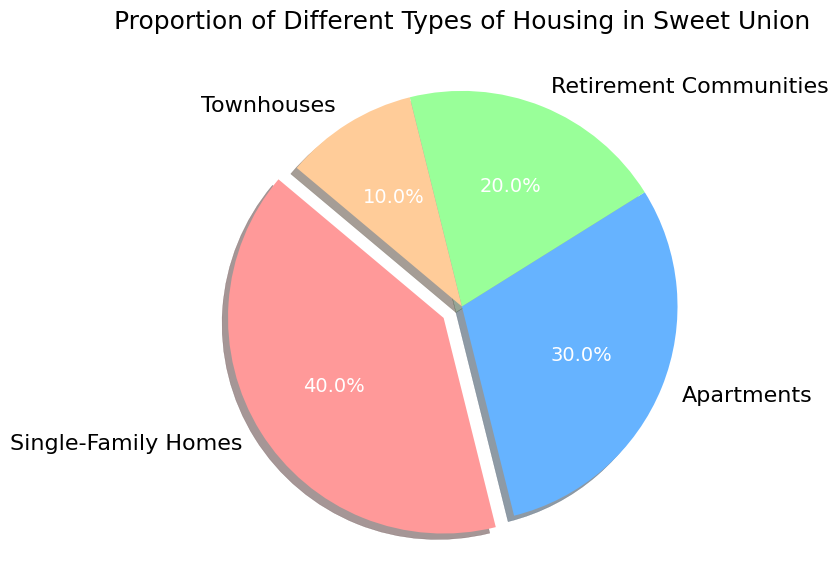Which type of housing has the largest proportion? The single-family homes segment takes up the majority of the pie chart, visually representing the largest slice.
Answer: Single-Family Homes Which two types of housing make up a combined proportion of 70%? The single-family homes and apartments segments together contribute to the pie chart, forming a combined 40% + 30% = 70%.
Answer: Single-Family Homes and Apartments What is the difference in proportion between retirement communities and townhouses? The retirement communities segment is larger by 20% - 10% = 10% when compared to the townhouses segment.
Answer: 10% Which type of housing has the smallest proportion? The townhouses segment occupies the smallest space in the pie chart, indicating the smallest proportion.
Answer: Townhouses Are apartments more prevalent than retirement communities? Yes, the apartments segment (30%) is larger than the retirement communities segment (20%) when visualized on the chart.
Answer: Yes What proportion of housing types are not single-family homes? Adding the percentages of apartments, retirement communities, and townhouses gives 30% + 20% + 10% = 60%.
Answer: 60% What is the average proportion of apartments and townhouses? The sum of the proportions of apartments and townhouses is 30% + 10% = 40%. The average is 40% / 2 = 20%.
Answer: 20% Is the sum of the proportions of single-family homes and retirement communities greater than that of apartments and townhouses? The sum of single-family homes and retirement communities is 40% + 20% = 60%. The sum of apartments and townhouses is 30% + 10% = 40%. 60% is greater than 40%.
Answer: Yes Which housing type has a highlighted slice in the chart? The single-family homes section is emphasized with the exploded slice in the pie chart.
Answer: Single-Family Homes 